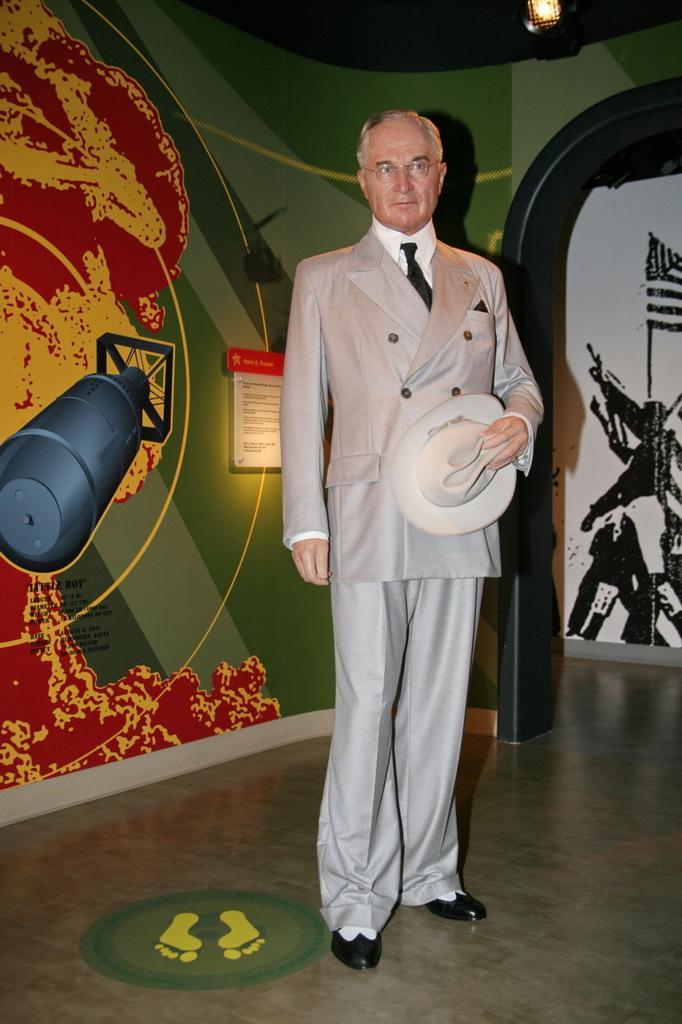Describe this image in one or two sentences. The picture is taken in a room. In the center of the picture there is a person standing wearing a suit and holding a hat. In the background there is a wall with posters attached to it. On the right there is a door. At the top right there is a light. 